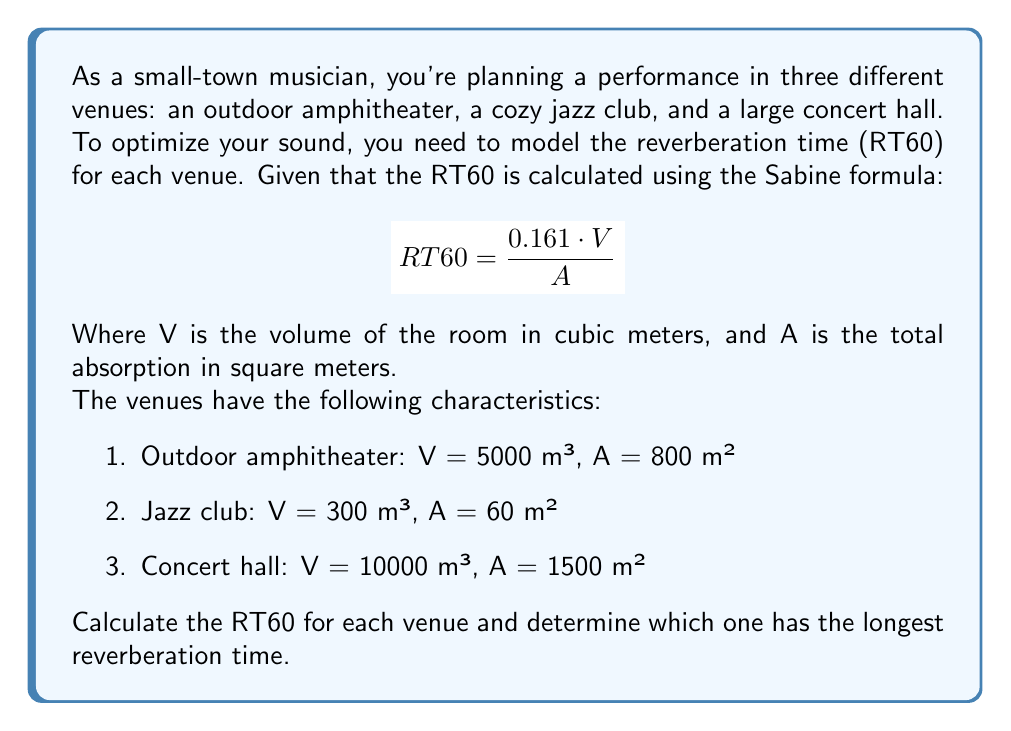Can you answer this question? To solve this problem, we need to apply the Sabine formula for each venue and compare the results. Let's calculate the RT60 for each venue step by step:

1. Outdoor amphitheater:
   $$RT60_{amphitheater} = \frac{0.161 \cdot 5000}{800} = \frac{805}{800} = 1.00625 \text{ seconds}$$

2. Jazz club:
   $$RT60_{jazz club} = \frac{0.161 \cdot 300}{60} = \frac{48.3}{60} = 0.805 \text{ seconds}$$

3. Concert hall:
   $$RT60_{concert hall} = \frac{0.161 \cdot 10000}{1500} = \frac{1610}{1500} = 1.07333 \text{ seconds}$$

Now, let's compare the results:
- Outdoor amphitheater: 1.00625 seconds
- Jazz club: 0.805 seconds
- Concert hall: 1.07333 seconds

The venue with the longest reverberation time is the concert hall with an RT60 of 1.07333 seconds.
Answer: Concert hall, 1.07333 seconds 